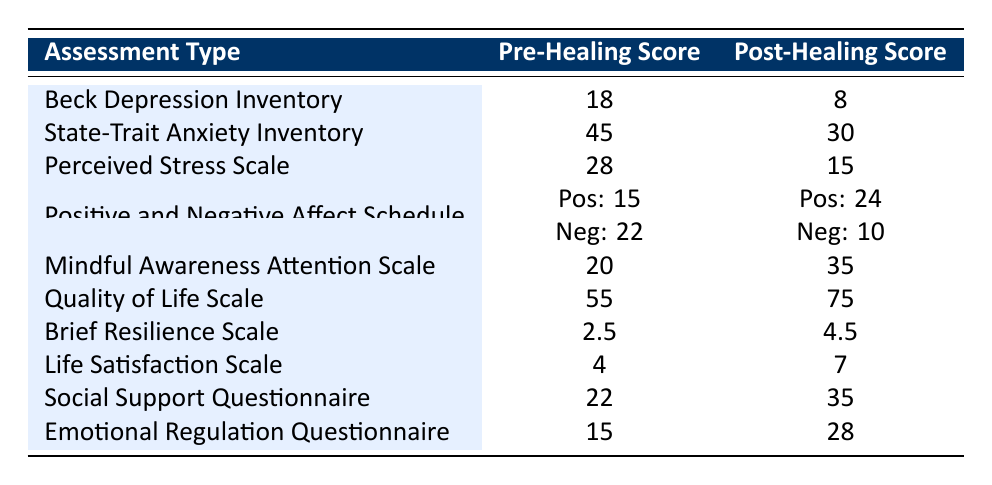What was the pre-healing score for the Beck Depression Inventory? The pre-healing score for the Beck Depression Inventory is found in the table under the correct assessment type. It is directly listed as 18.
Answer: 18 What is the post-healing score for the participant who completed the Social Support Questionnaire? To find the post-healing score, locate the Social Support Questionnaire in the table. The post-healing score listed next to it is 35.
Answer: 35 Which assessment showed the largest decrease in score from pre-healing to post-healing? For each assessment, calculate the difference between pre-healing and post-healing scores. The difference for the Beck Depression Inventory is 18 - 8 = 10. For the State-Trait Anxiety Inventory, it is 45 - 30 = 15, and for the Perceived Stress Scale, it is 28 - 15 = 13. The largest decrease is seen in the State-Trait Anxiety Inventory with a decrease of 15.
Answer: State-Trait Anxiety Inventory What is the difference between the pre-healing and post-healing scores for the Positive and Negative Affect Schedule? The pre-healing scores sum up to 15 for positive and 22 for negative, totaling 37. The post-healing scores are 24 for positive and 10 for negative, totaling 34. The difference between these totals is 37 - 34 = 3.
Answer: 3 Was there an improvement in the Quality of Life Scale scores after the healing? To evaluate improvement, compare the pre-healing score of 55 to the post-healing score of 75. Since 75 is greater than 55, this indicates an improvement.
Answer: Yes Which assessment type had the lowest pre-healing score? Review the pre-healing scores listed in the table. They are 18, 45, 28, 15 (positive mood), 22 (negative mood), 20, 55, 2.5, 4, 22, and 15. The lowest score is 2.5 from the Brief Resilience Scale.
Answer: Brief Resilience Scale Calculate the average post-healing score for all assessments, excluding the Positive and Negative Affect Schedule. First, list the post-healing scores: 8, 30, 15, 35, 75, 4.5, 7, 35, 28 (excluding Positive and Negative Affect Schedule scores). These sum to 8 + 30 + 15 + 35 + 75 + 4.5 + 7 + 35 + 28 = 333. There are 9 assessments total. The average is 333 / 9 ≈ 37. This indicates that the average post-healing score is about 37.
Answer: Approximately 37 Did every participant experience a reduced score post-healing? Assess each pre-healing score against its post-healing counterpart for reduction. The scores for Mindful Awareness Attention Scale, Quality of Life Scale, Brief Resilience Scale, Life Satisfaction Scale, and Social Support Questionnaire increased post-healing. This means not every participant experienced a score decrease.
Answer: No 